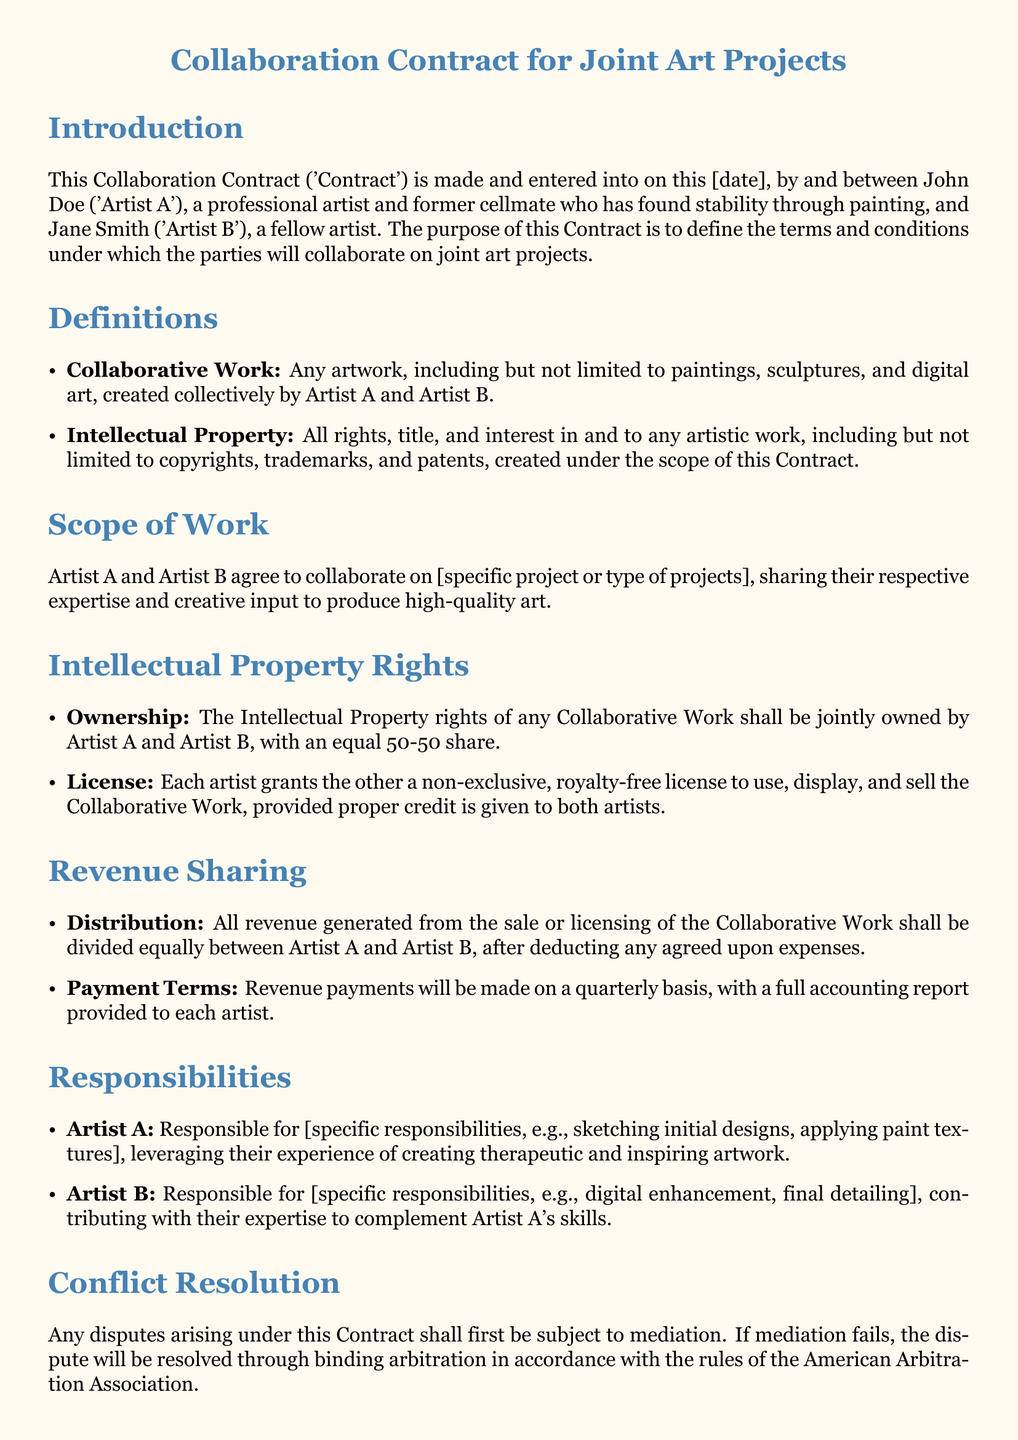What is the purpose of this contract? The purpose of the contract is to define the terms and conditions under which the parties will collaborate on joint art projects.
Answer: Terms and conditions for collaboration Who are the parties involved in the contract? The contract specifies the parties as Artist A and Artist B, identifying them by name.
Answer: John Doe and Jane Smith What is the revenue sharing percentage for each artist? The revenue sharing percentage is explicitly stated in the document as an equal division.
Answer: 50-50 What type of artwork is categorized as Collaborative Work? The document defines Collaborative Work as any artwork created collectively by both artists.
Answer: Any artwork created collectively What is required if either party wants to terminate the contract? The document outlines the requirement for termination to be a written notice period.
Answer: 30 days' written notice What happens to unfinished work if the contract is terminated? The document specifies that unfinished work will remain the Intellectual Property of both parties.
Answer: Remains Intellectual Property of both parties What is the conflict resolution method outlined in the contract? The contract states the method for resolving disputes as mediation followed by arbitration if needed.
Answer: Mediation and arbitration How often are revenue payments made according to the contract? The document specifies the frequency of revenue payments made to the artists.
Answer: Quarterly basis 